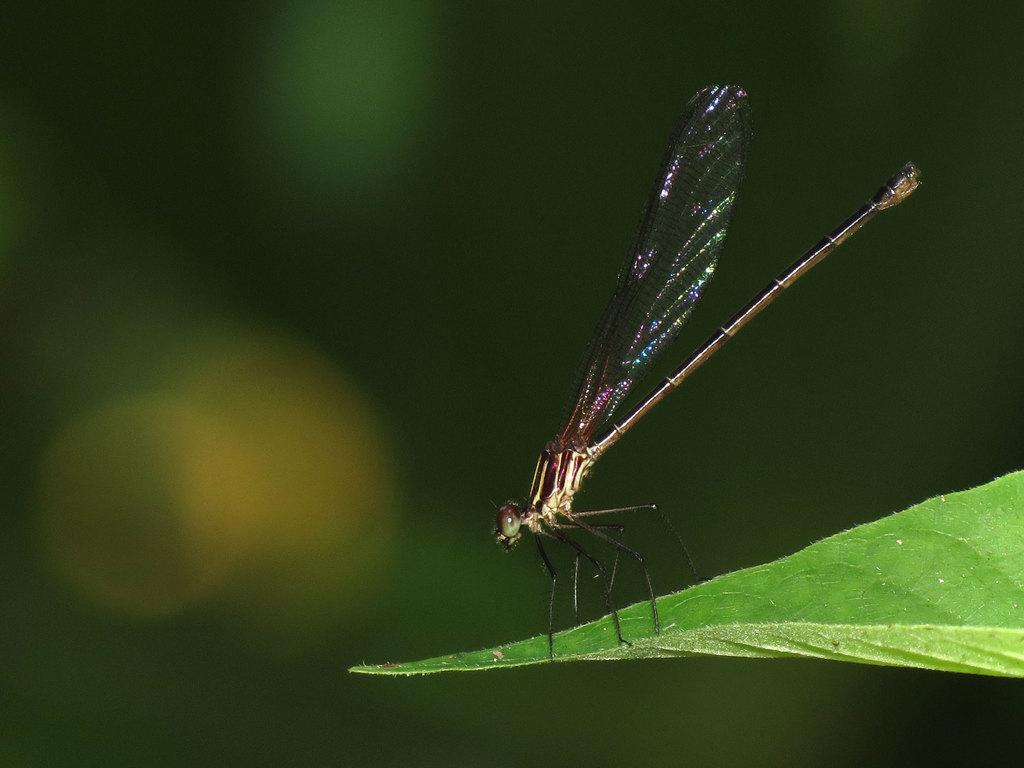What is present in the image? There is a fly in the image. Where is the fly located? The fly is on a leaf. What role does the head play in the image? There is no reference to a head or any actors in the image, so it is not possible to answer that question. 